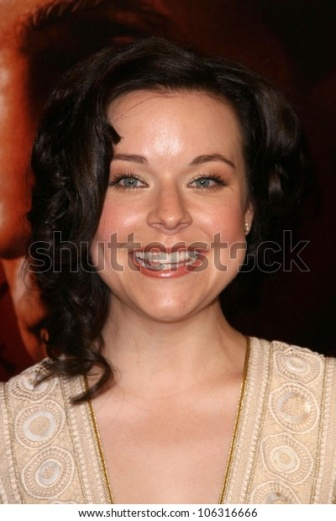Describe the context in which this image was taken. This image was likely taken at a glamorous event such as a red carpet ceremony, a movie premiere, or an award show. The woman, dressed elegantly in a beige dress with circular patterns and subtle earrings, is the focal point of this photo. The blurred red background suggests the presence of other attendees, media, and perhaps bright lights, creating a bustling, high-energy atmosphere. The image captures a moment of joy, sophistication, and public admiration. Imagine what might happen next in this event. As the event continues, the woman might proceed down the red carpet, stopping occasionally to pose for photographers and give interviews. She could engage in friendly conversations with fellow guests or even meet some of her idols. The evening might include a screening of a film, or an award presentation, followed by a lavish reception where attendees can mingle, enjoy fine dining, and celebrate the highlights of the night. 